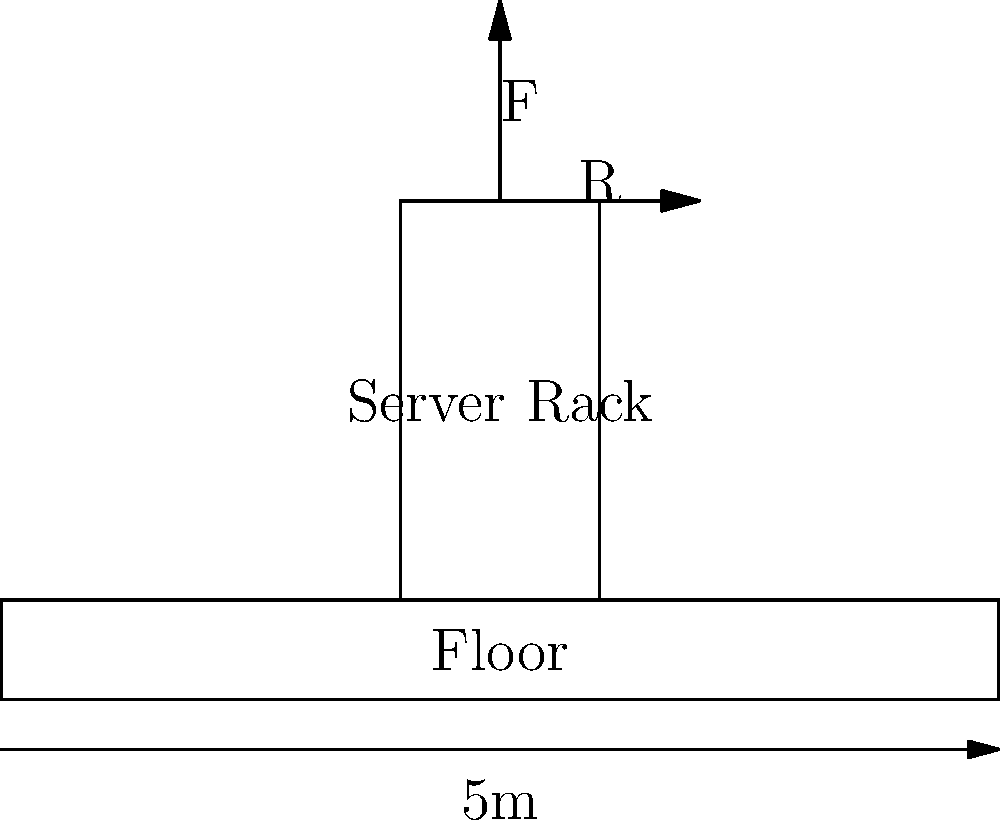A server rack weighing 1000 kg is placed on a 5m wide server room floor. If the rack's base is 1m wide and centered on the floor, calculate the maximum bending moment experienced by the floor. Assume the floor behaves as a simply supported beam. To solve this problem, we'll follow these steps:

1. Identify the given information:
   - Server rack weight = 1000 kg
   - Floor width = 5 m
   - Rack base width = 1 m

2. Convert the weight to force:
   $F = mg = 1000 \text{ kg} \times 9.8 \text{ m/s}^2 = 9800 \text{ N}$

3. Treat the floor as a simply supported beam with the load at the center:
   - Beam length (L) = 5 m
   - Load (P) = 9800 N
   - Load position = center (2.5 m from each end)

4. Calculate the reaction forces at the supports:
   Due to symmetry, each support bears half the load.
   $R_1 = R_2 = \frac{P}{2} = \frac{9800 \text{ N}}{2} = 4900 \text{ N}$

5. The maximum bending moment occurs at the center of the beam where the load is applied. For a simply supported beam with a point load at the center, the maximum bending moment is given by:

   $M_{max} = \frac{PL}{4}$

   Where:
   $P$ is the applied load
   $L$ is the length of the beam

6. Substitute the values:
   $M_{max} = \frac{9800 \text{ N} \times 5 \text{ m}}{4} = 12250 \text{ N}\cdot\text{m}$

Therefore, the maximum bending moment experienced by the floor is 12250 N·m.
Answer: 12250 N·m 